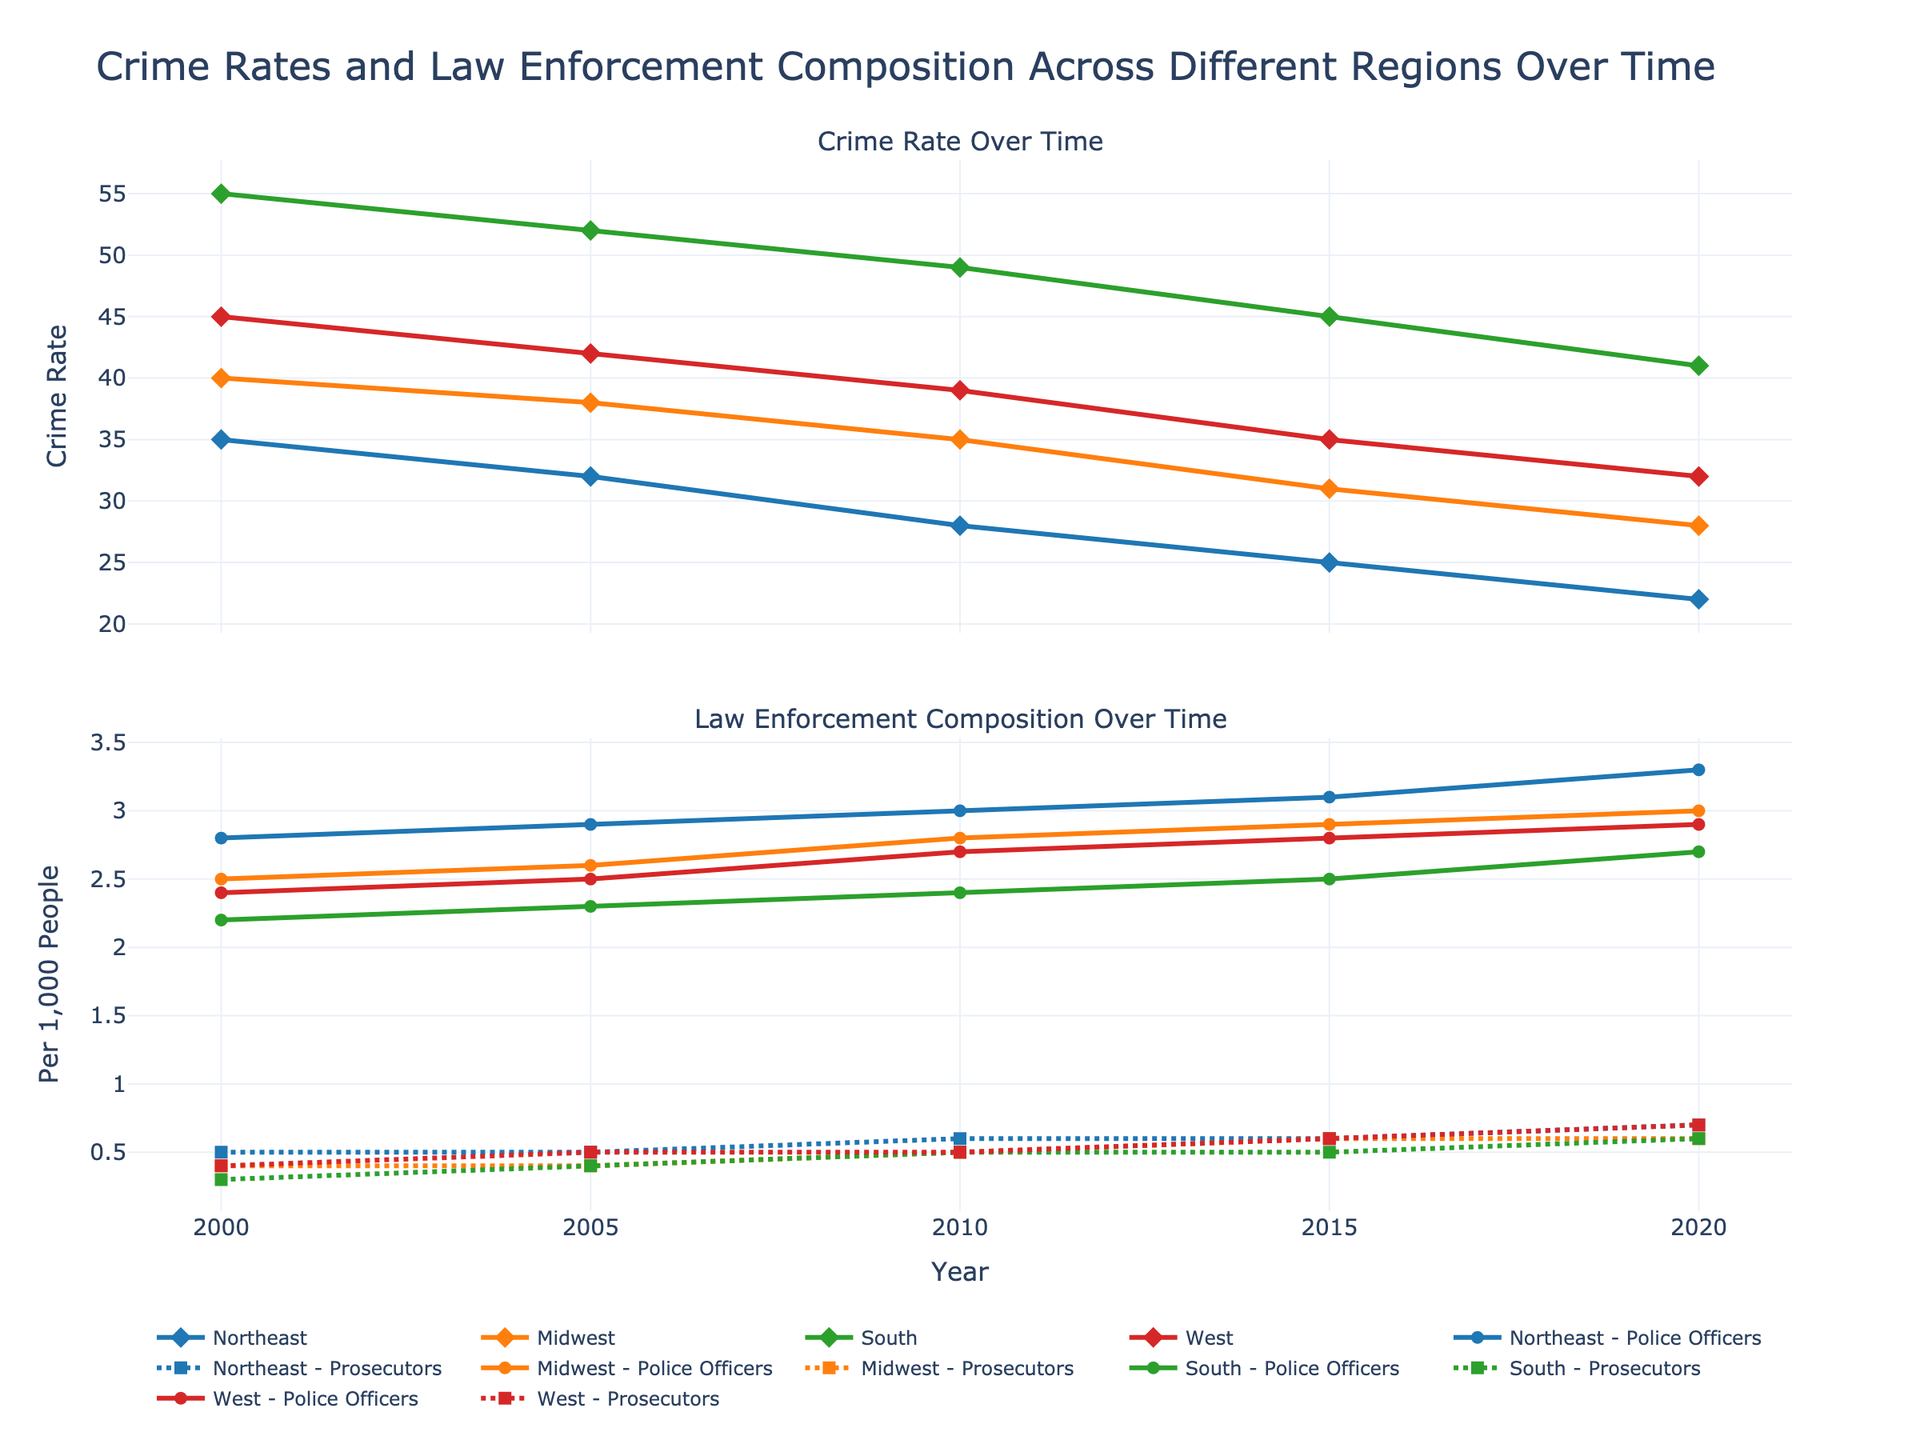What is the trend in crime rate in the Northeast region from 2000 to 2020? From the figure, observe the line representing the Northeast region in the crime rate plot. It shows a downward trend from 2000 (35) to 2020 (22).
Answer: Downward How does the number of police officers per 1000 people change in the Midwest from 2000 to 2020? Refer to the law enforcement composition plot and focus on the Midwest line for police officers. It increases from 2.5 in 2000 to 3.0 in 2020.
Answer: Increases Which region had the highest crime rate in 2020? Examine the crime rate plot for the year 2020. The South region has the highest crime rate (41) compared to other regions.
Answer: South What is the difference between the number of prosecutors per 1000 people in the Northeast and the South in 2020? In the law enforcement composition plot for 2020, the Northeast has 0.7 prosecutors per 1000 people, while the South has 0.6. The difference is 0.7 - 0.6 = 0.1.
Answer: 0.1 Compare the trends of police officers per 1000 people between the South and the West. In the law enforcement composition plot, both regions show an increasing trend from 2000 to 2020. However, the South starts at a lower value (2.2) and ends at 2.7, while the West starts at 2.4 and ends at 2.9.
Answer: Both increasing What is the average crime rate across all regions in the year 2010? Arithmetic mean of crime rates: (Northeast 28 + Midwest 35 + South 49 + West 39) / 4 = 151 / 4.
Answer: 37.75 Which region showed the most significant decrease in crime rate from 2000 to 2020? Compare the changes: Northeast (-13), Midwest (-12), South (-14), West (-13). The South has the greatest decrease of 14 units.
Answer: South What pattern can be identified in the crime rates of the Midwest region over the given years? The pattern in the crime rate of the Midwest region shows a consistent decline from 2000 (40) to 2020 (28).
Answer: Declining trend 